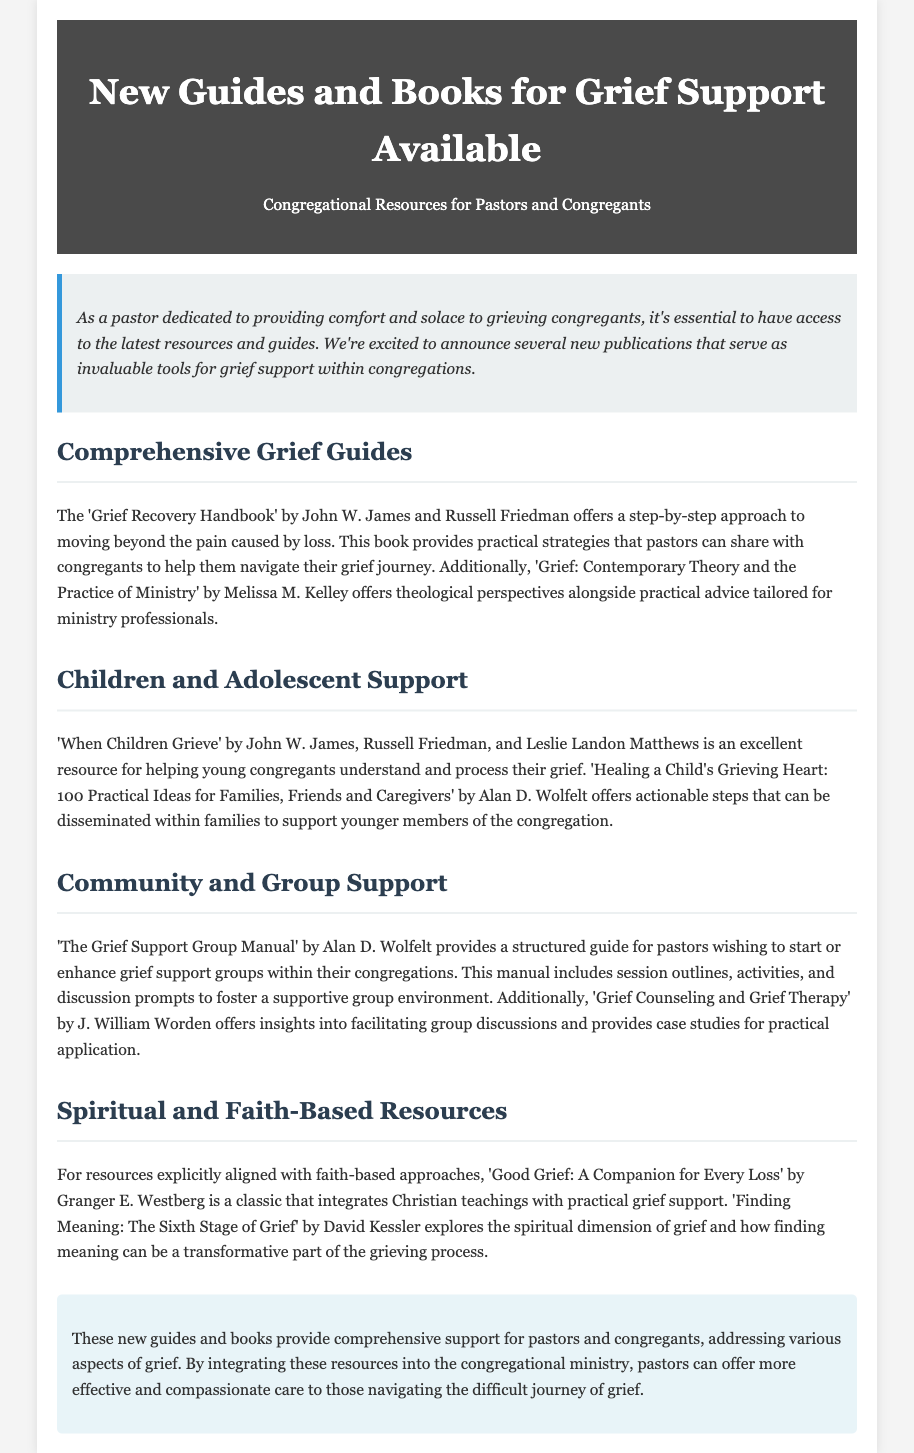What is the title of the press release? The title clearly states the subject of the document, which is presented at the top.
Answer: New Guides and Books for Grief Support Available Who are the authors of 'Grief Recovery Handbook'? The document lists the authors of this book within the description of the comprehensive grief guides.
Answer: John W. James and Russell Friedman What does 'When Children Grieve' aim to help with? The document describes the purpose of this book in relation to its target audience, specifically focusing on young congregants.
Answer: Help young congregants understand and process their grief What is the focus of 'Good Grief: A Companion for Every Loss'? The document explains the primary theme of this resource in relation to faith-based grief support.
Answer: Integrates Christian teachings with practical grief support How many practical ideas does 'Healing a Child's Grieving Heart' provide? The document mentions this specific number in the title of the book, indicating the number of actionable steps it offers.
Answer: 100 What type of manual is 'The Grief Support Group Manual'? The document refers to this resource and its purpose as part of community and group support.
Answer: Structured guide What is the central theme of 'Finding Meaning: The Sixth Stage of Grief'? The document describes the focus of this book regarding the grieving process and spirituality.
Answer: Explores the spiritual dimension of grief Which author wrote both a contemporary theory book and a grief recovery handbook? The document includes multiple mentions of this author's works within different contexts.
Answer: John W. James 